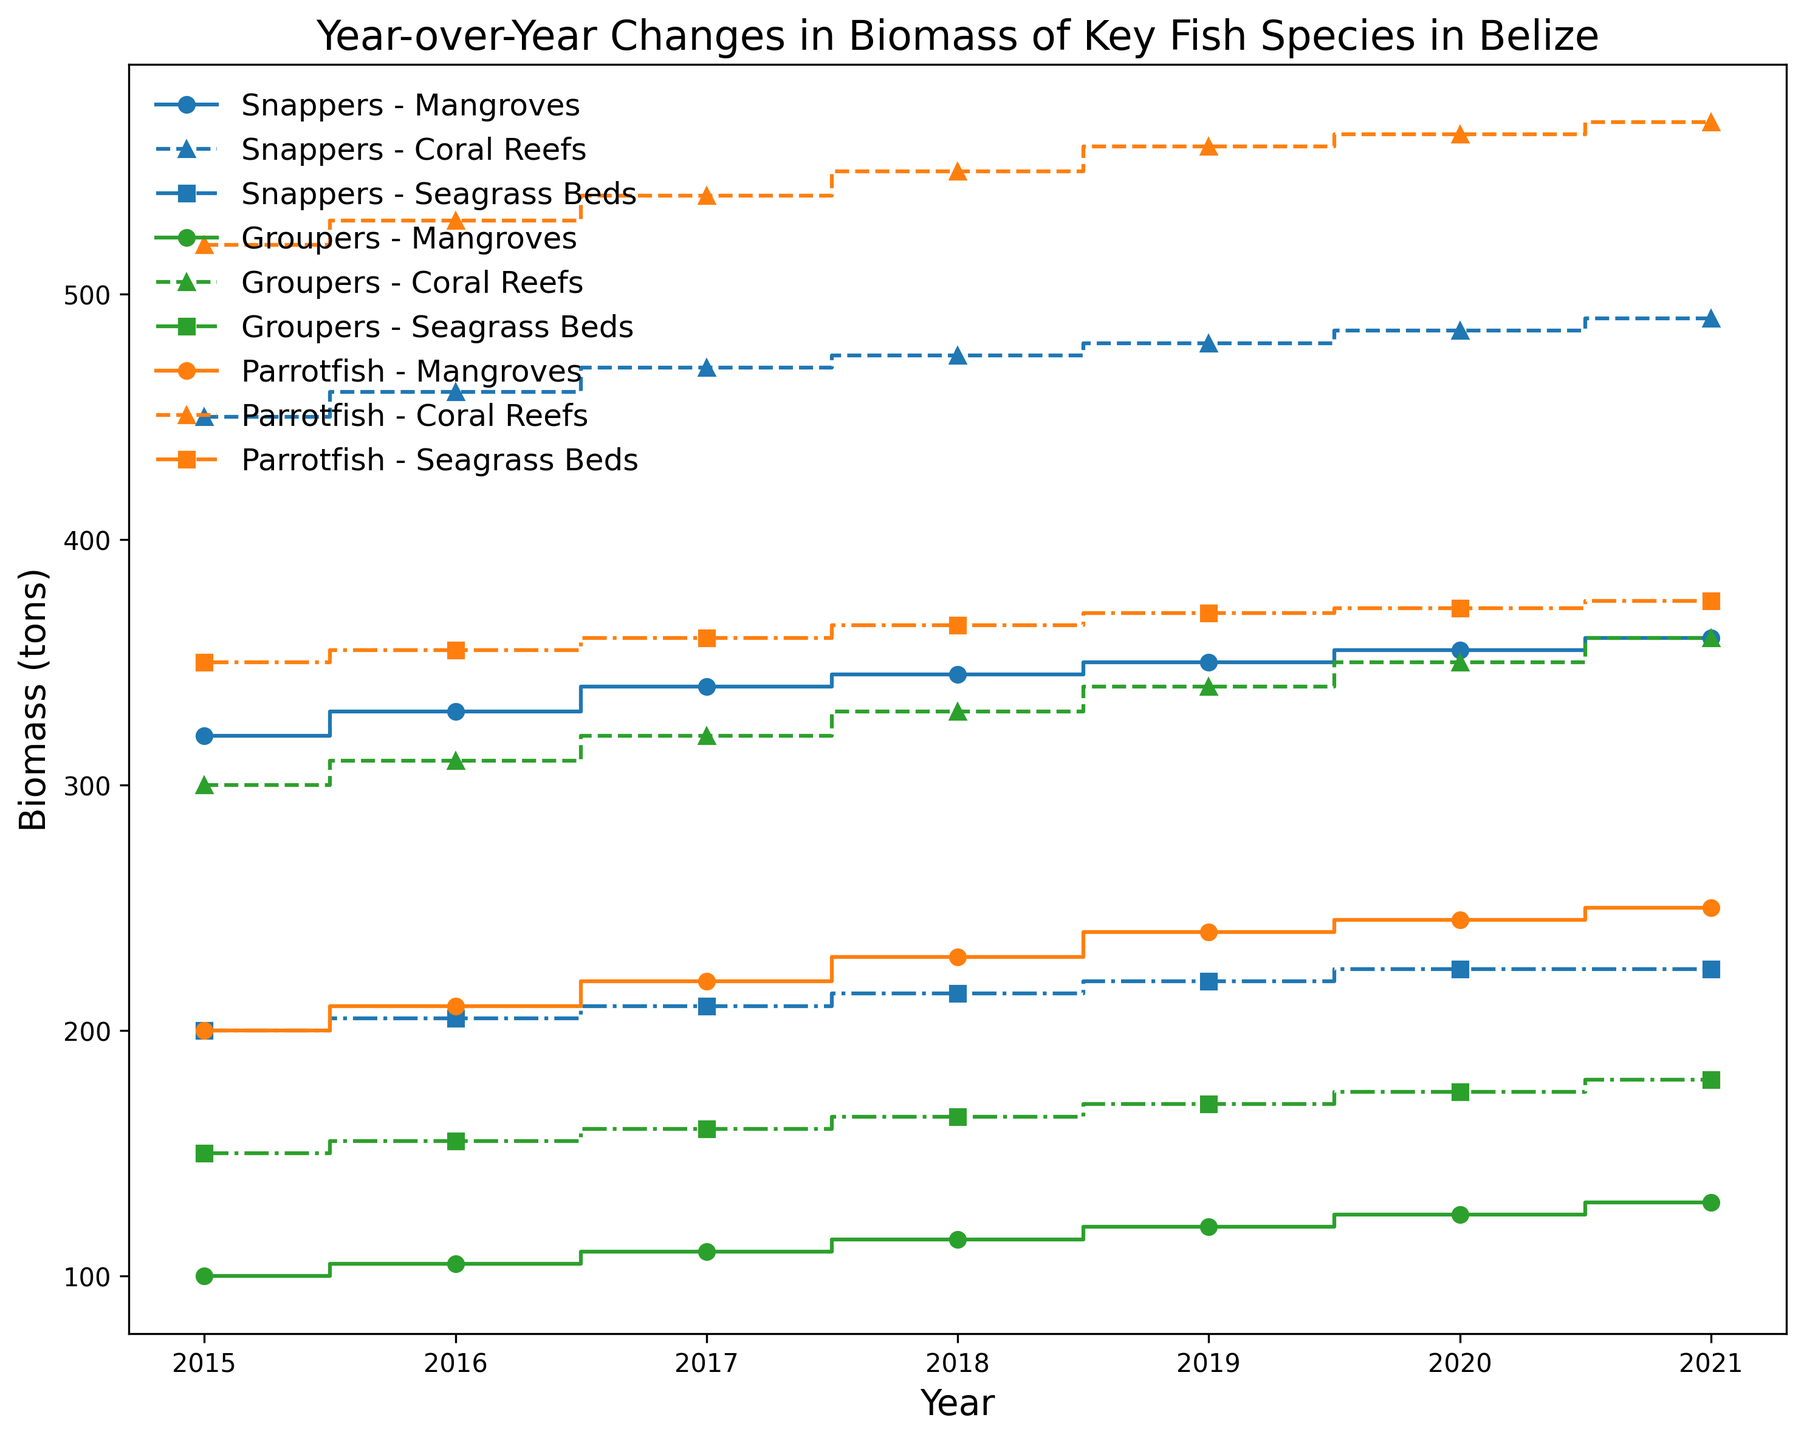What is the trend in biomass of Snappers in coral reefs from 2015 to 2021? The step plot shows a consistent increase in the biomass of Snappers in coral reefs from 450 tons in 2015 to 490 tons in 2021. Each year, the biomass increases by approximately 10 tons.
Answer: Consistent increase Which habitat type has the highest biomass for Parrotfish throughout the years? By observing the step plot, the coral reefs line for Parrotfish is consistently the highest among the three habitat types from 2015 to 2021.
Answer: Coral reefs Comparing 2021, which species has the highest biomass in seagrass beds, and what is the value? The lines for Snappers, Groupers, and Parrotfish in 2021 for seagrass beds can be compared. Parrotfish has the highest biomass at 375 tons.
Answer: Parrotfish, 375 tons What is the difference in biomass of Groupers in mangroves between 2015 and 2020? In 2015, the biomass of Groupers in mangroves is 100 tons. In 2020, it is 125 tons. The difference can be calculated as 125 - 100 = 25 tons.
Answer: 25 tons How much did the biomass of Snappers in seagrass beds change from 2018 to 2020? The biomass of Snappers in seagrass beds increased from 215 tons in 2018 to 225 tons in 2020. The difference is 225 - 215 = 10 tons.
Answer: 10 tons Which fish species shows the most significant increase in biomass in coral reefs from 2015 to 2021? Comparing the step lines for Snappers, Groupers, and Parrotfish in coral reefs, Parrotfish shows an increase from 520 tons in 2015 to 570 tons in 2021, the most significant increase of 50 tons.
Answer: Parrotfish What is the combined biomass of all three fish species in mangroves in the year 2017? Adding the values from the lines at year 2017: Snappers (340 tons), Groupers (110 tons), Parrotfish (220 tons). Combined biomass is 340 + 110 + 220 = 670 tons.
Answer: 670 tons Which habitat type saw the least variability in biomass for Groupers over the years? The step plot shows that the biomass line for Groupers in seagrass beds has the least steepness compared to mangroves and coral reefs, indicating the least variability.
Answer: Seagrass beds By how much did the biomass of Parrotfish in seagrass beds increase from 2019 to 2021? In 2019, the biomass of Parrotfish in seagrass beds was 370 tons. In 2021, it was 375 tons, resulting in an increase of 375 - 370 = 5 tons.
Answer: 5 tons In which year and habitat type did the biomass of Groupers exceed 300 tons for the first time? According to the step plot for Groupers in coral reefs, the biomass exceeded 300 tons for the first time in 2016 when it reached 310 tons.
Answer: 2016, coral reefs 